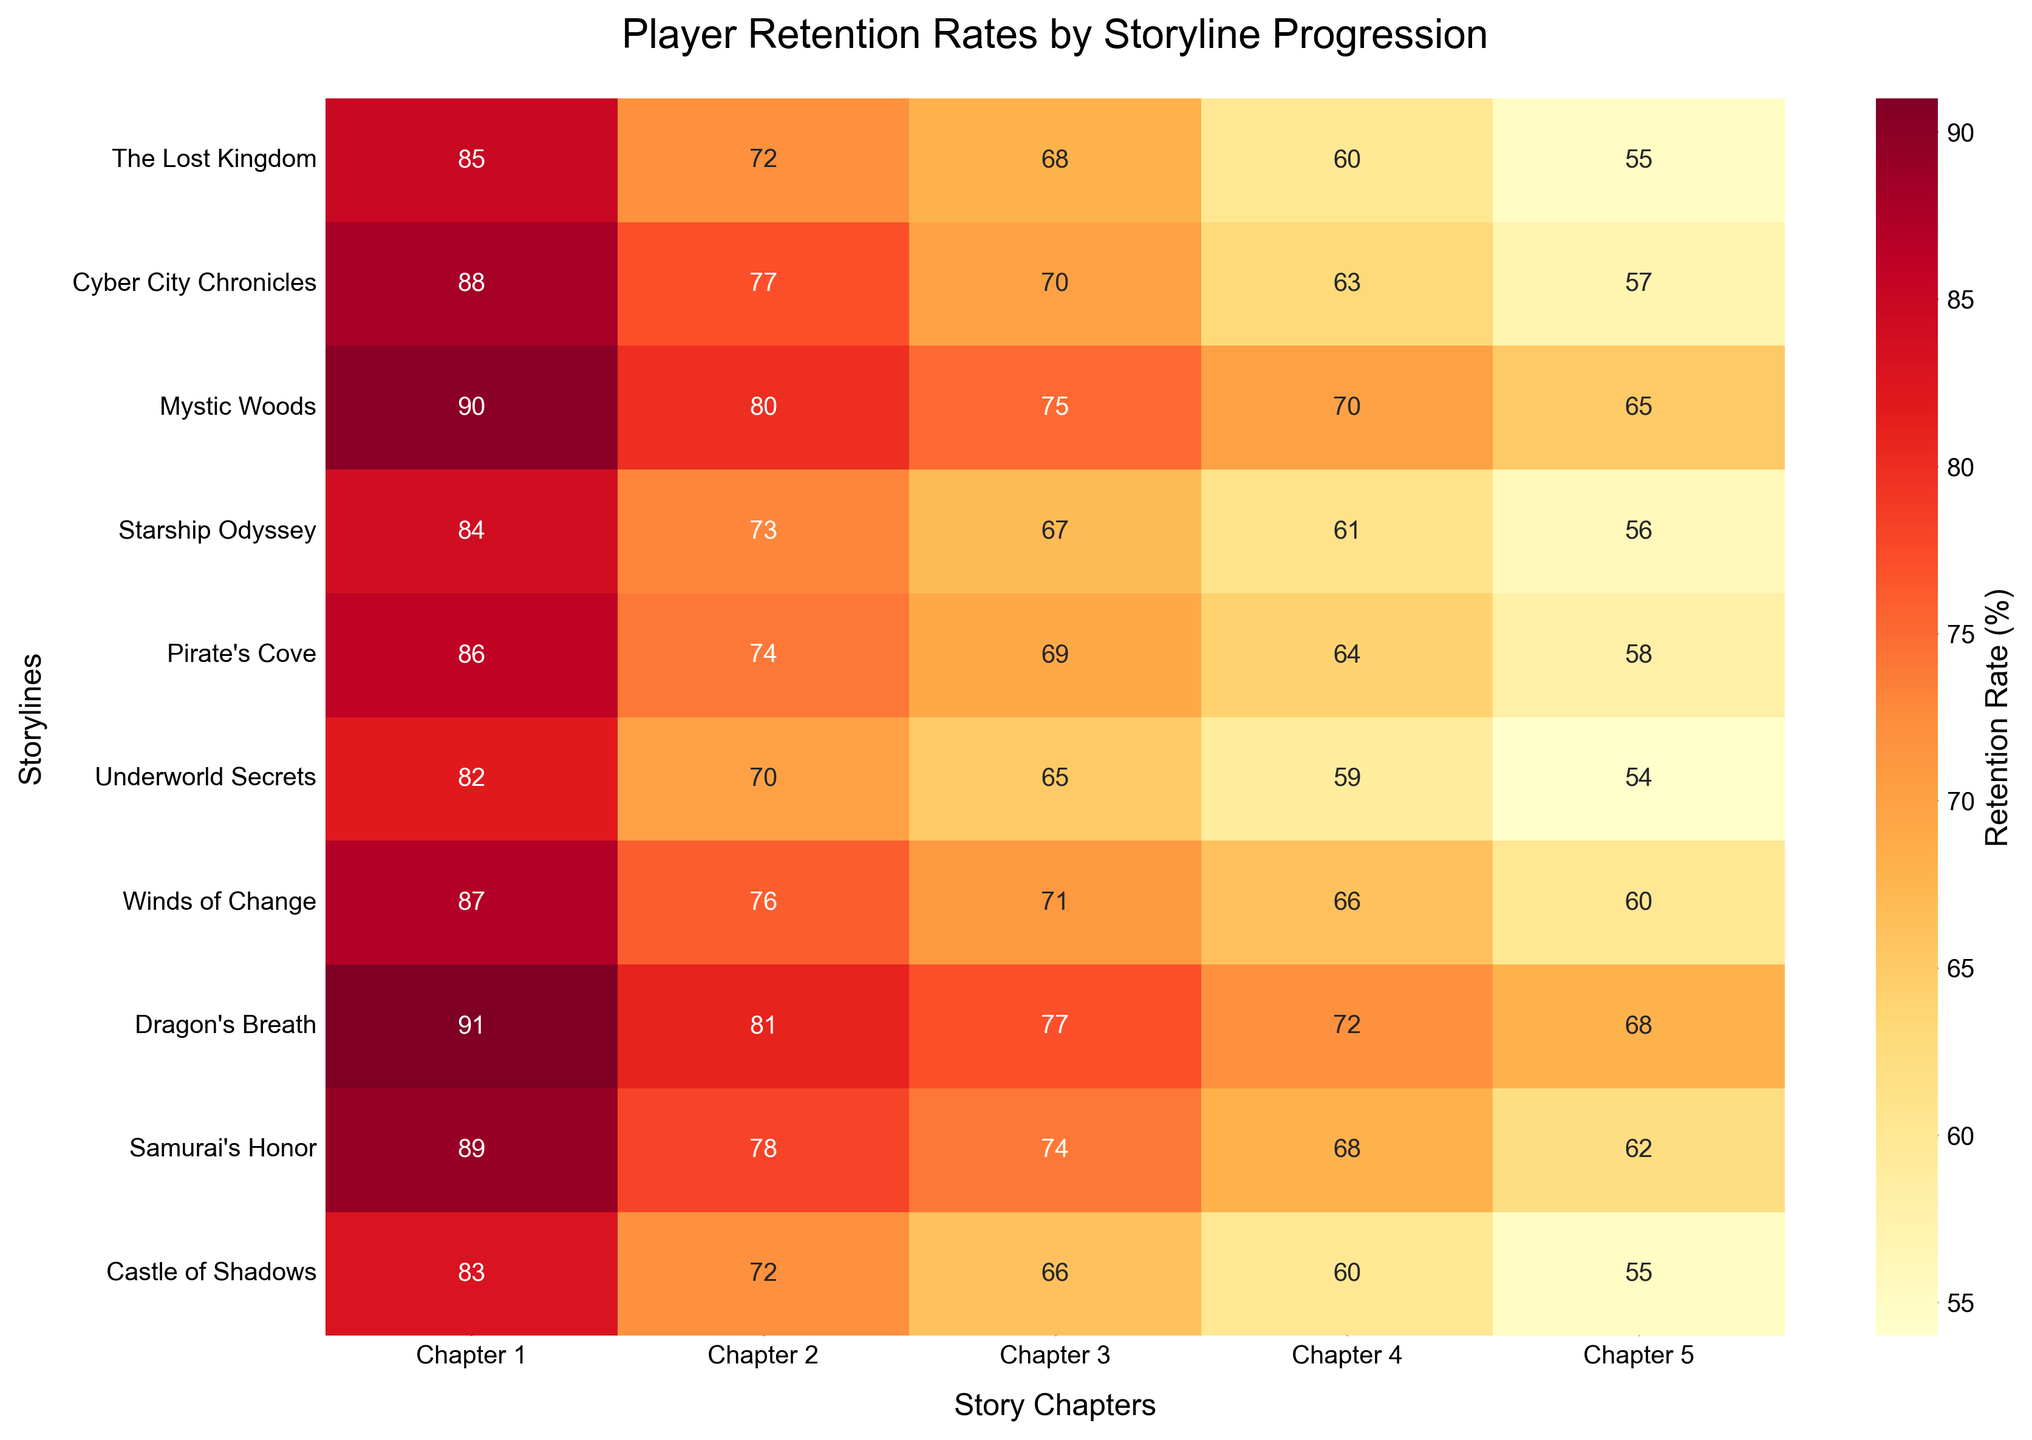What is the retention rate for "Mystic Woods" in Chapter 3? Locate "Mystic Woods" in the rows and Chapter 3 in the columns. The retention rate at their intersection is 75%
Answer: 75% Which storyline has the highest retention rate in Chapter 5? Compare the retention rates for Chapter 5 across all storylines. "Dragon's Breath" has the highest rate at 68%
Answer: "Dragon's Breath" What is the average retention rate for "Underworld Secrets" across all chapters? Sum the retention rates for "Underworld Secrets" and divide by the number of chapters: (82 + 70 + 65 + 59 + 54) / 5 = 66%
Answer: 66% How does the retention rate for "Starship Odyssey" in Chapter 2 compare to "Pirate's Cove" in the same chapter? The retention rate for "Starship Odyssey" in Chapter 2 is 73%, and for "Pirate's Cove," it's 74%. So, "Pirate's Cove" has a slightly higher rate
Answer: "Pirate's Cove" is higher Which chapter has the overall lowest average retention rate across all storylines? Calculate the average retention rate for each chapter and compare: Chapter 5 has the lowest average rate (55+57+65+56+58+54+60+68+62+55) / 10 = 59%
Answer: Chapter 5 What is the retention rate difference between Chapter 1 and Chapter 5 for "Samurai's Honor"? The retention rate for Chapter 1 is 89% and for Chapter 5 is 62%. The difference is 89% - 62% = 27%
Answer: 27% Which two storylines have almost the same retention rates in Chapter 3? Compare the retention rates in Chapter 3 across storylines. "The Lost Kingdom" (68%) and "Starship Odyssey" (67%) have similar rates
Answer: "The Lost Kingdom" and "Starship Odyssey" What trend can be observed in the retention rates across chapters for "Winds of Change"? The retention rates decrease from Chapter 1 (87%) to Chapter 5 (60%), showing a downward trend
Answer: Downward trend Are there any storylines where retention rates increase in any chapter? Check each storyline's retention rates across chapters. All storylines show a decrease; none have increased retention rates in any chapter
Answer: No What is the combined retention rate for "The Lost Kingdom" in Chapters 1, 3, and 5? Sum the retention rates for "The Lost Kingdom" in Chapters 1 (85%), 3 (68%), and 5 (55%): 85 + 68 + 55 = 208%
Answer: 208% 